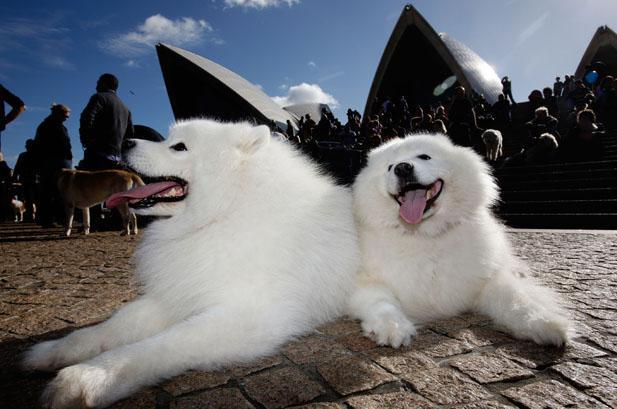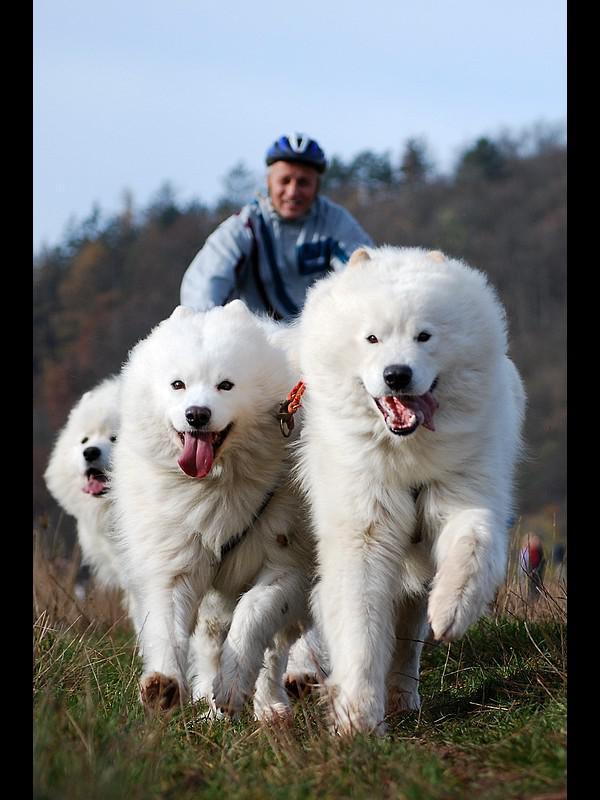The first image is the image on the left, the second image is the image on the right. Assess this claim about the two images: "An image shows one person behind three white dogs.". Correct or not? Answer yes or no. Yes. The first image is the image on the left, the second image is the image on the right. Analyze the images presented: Is the assertion "There are three Samoyed puppies in the left image." valid? Answer yes or no. No. 